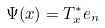<formula> <loc_0><loc_0><loc_500><loc_500>\Psi ( x ) = T ^ { * } _ { x } e _ { n }</formula> 